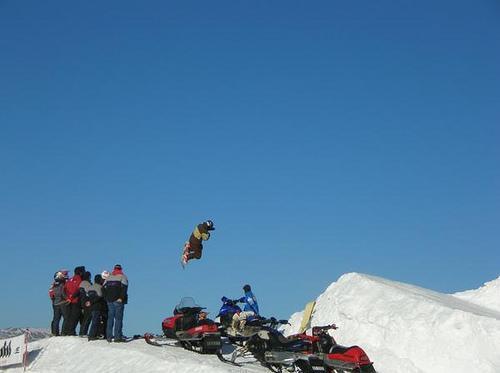How many skis is the man riding?
Give a very brief answer. 2. How many rolls of toilet paper are in the picture?
Give a very brief answer. 0. 